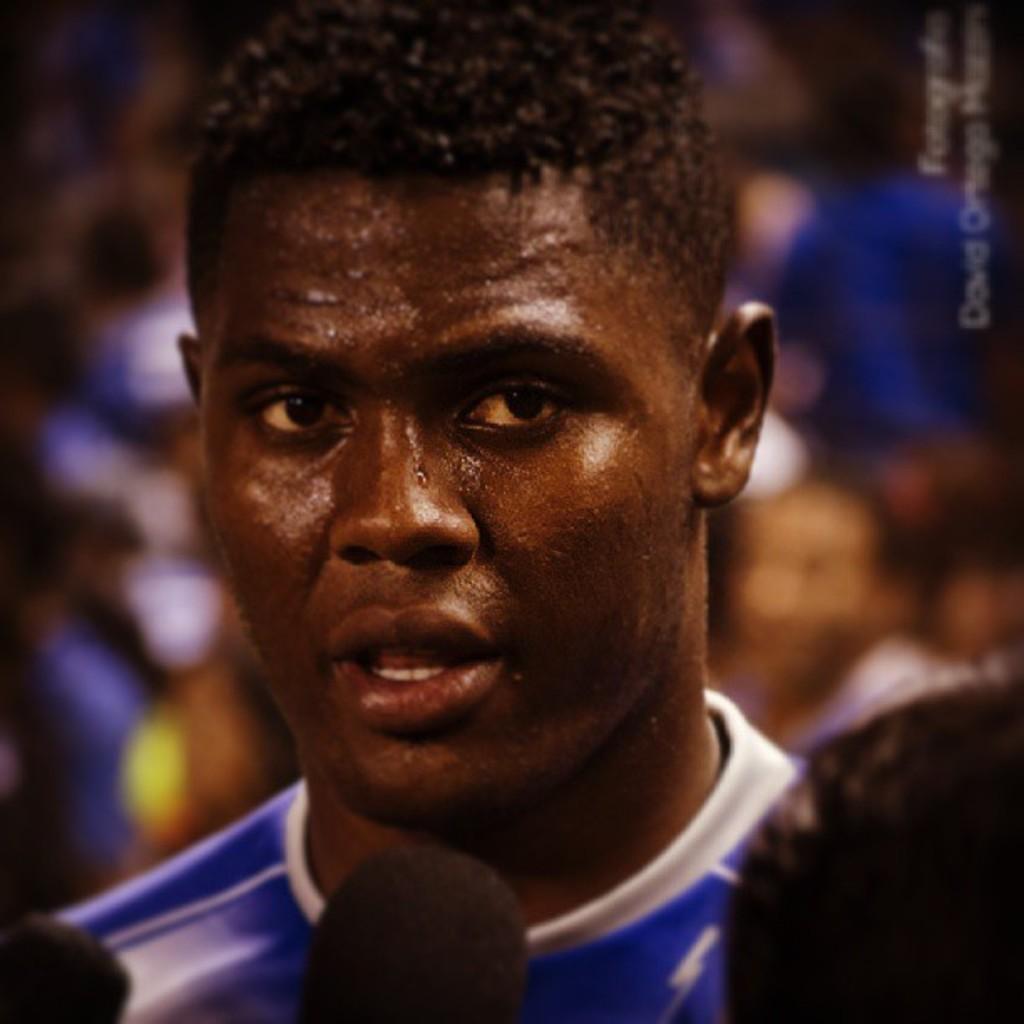Can you describe this image briefly? In this picture we can see few people and blurry background, in the top right hand corner we can see some text. 